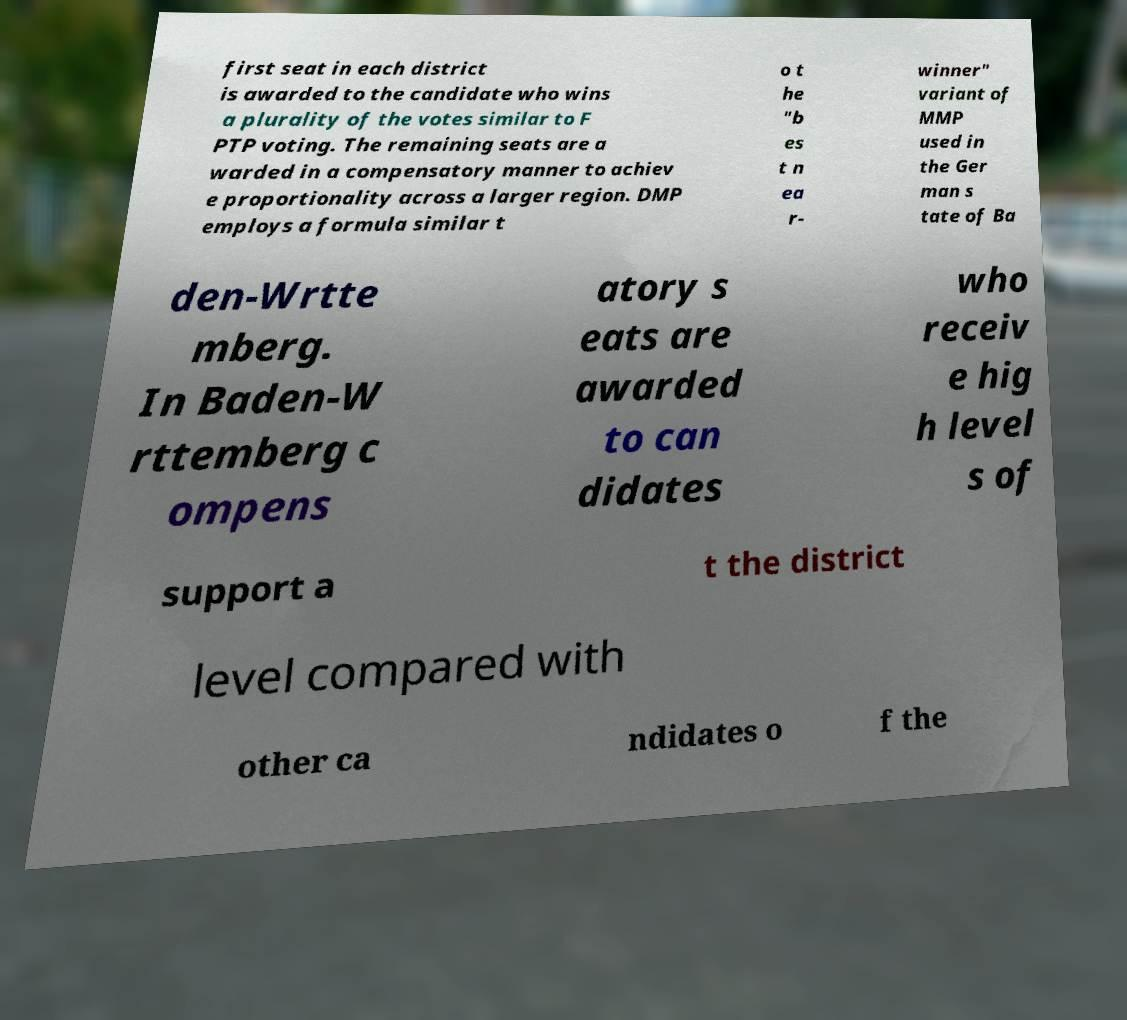What messages or text are displayed in this image? I need them in a readable, typed format. first seat in each district is awarded to the candidate who wins a plurality of the votes similar to F PTP voting. The remaining seats are a warded in a compensatory manner to achiev e proportionality across a larger region. DMP employs a formula similar t o t he "b es t n ea r- winner" variant of MMP used in the Ger man s tate of Ba den-Wrtte mberg. In Baden-W rttemberg c ompens atory s eats are awarded to can didates who receiv e hig h level s of support a t the district level compared with other ca ndidates o f the 